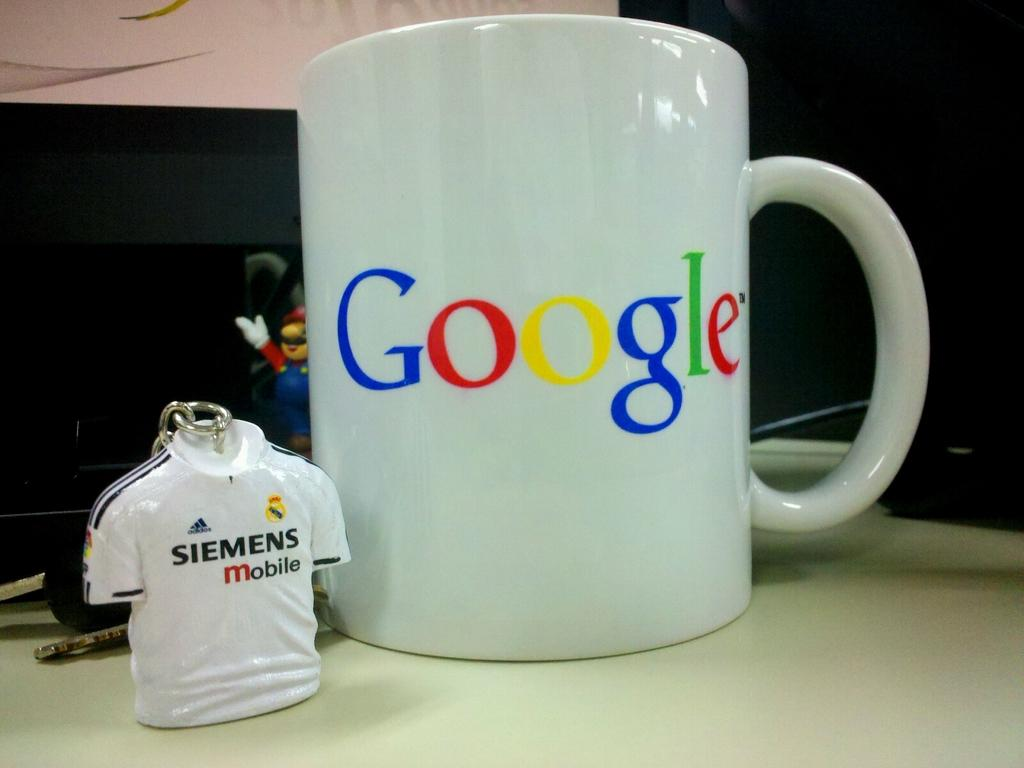<image>
Give a short and clear explanation of the subsequent image. Very colorful letters that spell Google on a coffee cup, next to a T-shirt key chain from Siemens. 